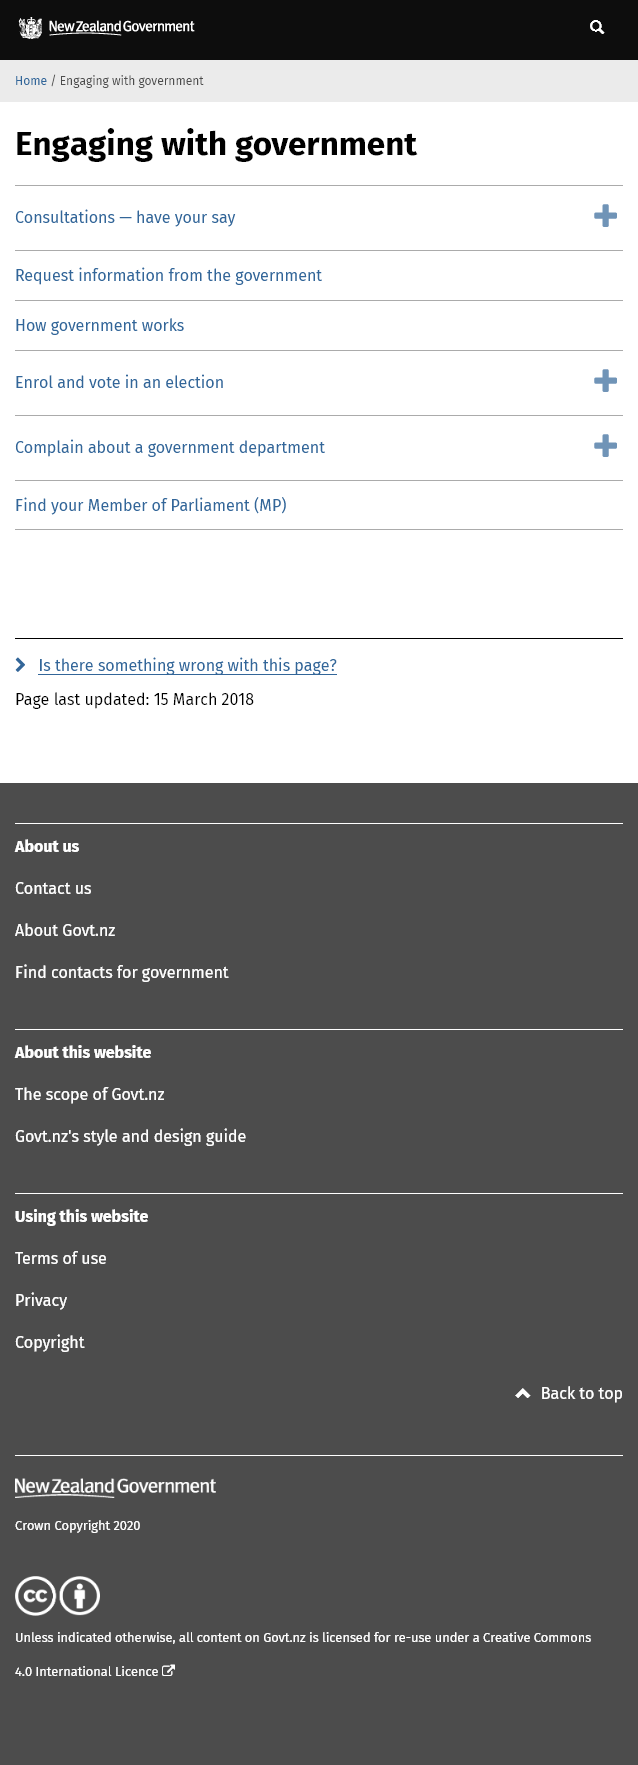Mention a couple of crucial points in this snapshot. I engage with government through various means, including links on the page. I, [Name], declare that I am a member of parliament. To learn about the functioning of the government, please click on the 'How the Government Works Button.' 